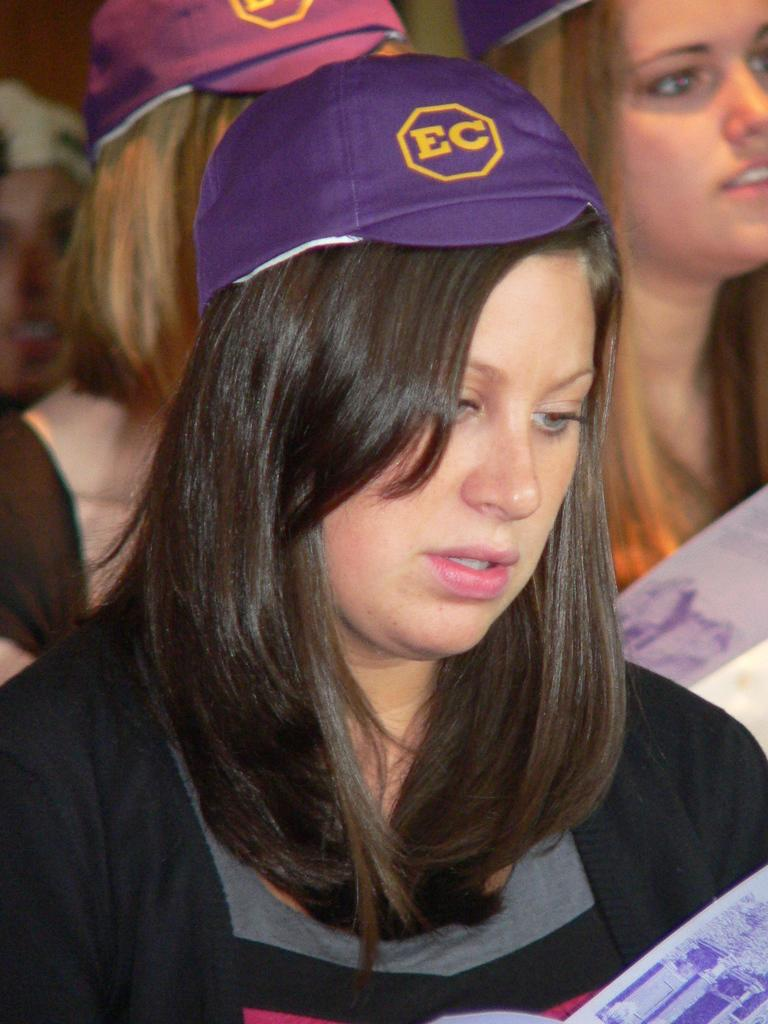<image>
Write a terse but informative summary of the picture. Women with ec hats sitting in chairs in a room 